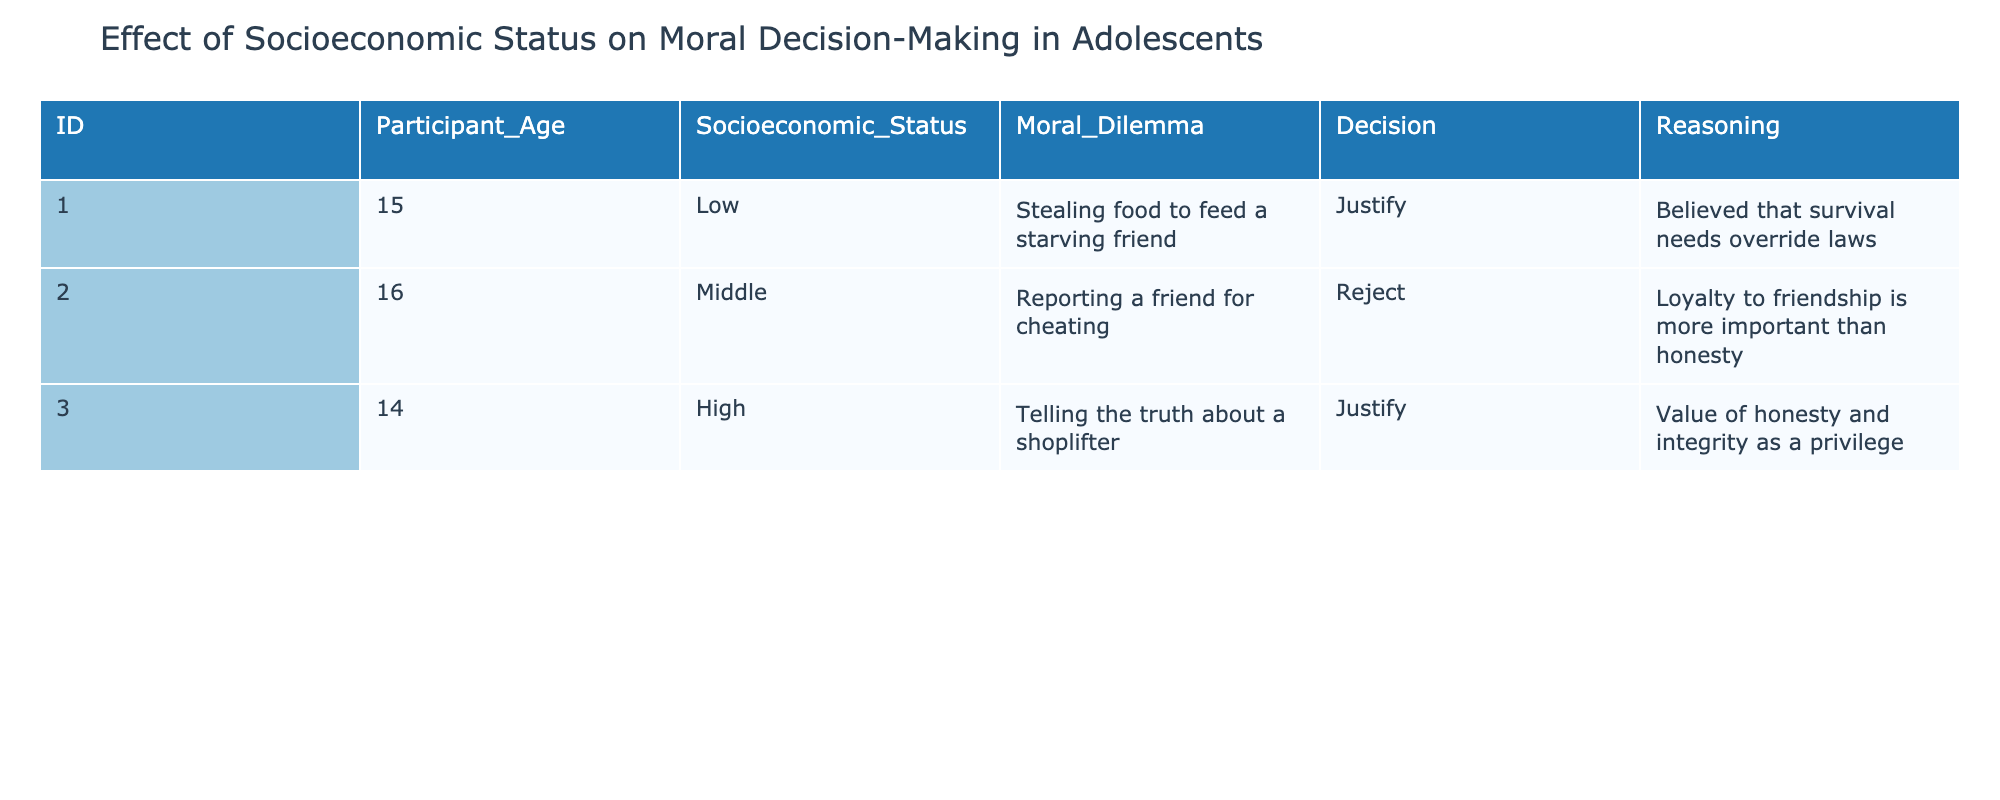What is the decision made by the participant aged 15 with low socioeconomic status? The table shows that the participant aged 15 with low socioeconomic status made the decision to "Justify" stealing food to feed a starving friend.
Answer: Justify How many participants reported a decision to justify their actions? There are two participants with justifications: one is aged 15 (low socioeconomic status) and the other is aged 14 (high socioeconomic status). Therefore, the total number is 2.
Answer: 2 Did the participant with high socioeconomic status decide to reject a moral dilemma? The participant aged 14 with high socioeconomic status chose to justify their decision regarding telling the truth about a shoplifter, thus did not reject a moral dilemma.
Answer: No What reasoning did the participant with middle socioeconomic status provide for rejecting the moral dilemma? The participant aged 16 with middle socioeconomic status reasoned that loyalty to friendship is more important than honesty, which explains their decision to reject reporting a friend for cheating.
Answer: Loyalty to friendship is more important than honesty What is the average age of participants who justified their decisions? The participants who justified their decisions are aged 15 and 14. To find the average: (15 + 14) / 2 = 29 / 2 = 14.5.
Answer: 14.5 How many decisions were made in total about moral dilemmas involving stealing? The table shows one decision regarding stealing food to feed a starving friend, which corresponds to just one case out of the three total participants.
Answer: 1 Did any participant justify their decision related to honesty? Yes, the participant aged 14 with high socioeconomic status justified telling the truth about a shoplifter, indicating a belief in the value of honesty and integrity.
Answer: Yes What percentage of the participants come from a low socioeconomic status? There are three participants in total, and only one participant is from a low socioeconomic status, which gives us (1/3) * 100 = 33.33%.
Answer: 33.33% What is the reasoning behind the decision made by the participant aged 16? The participant aged 16, who has a middle socioeconomic status, rejected the moral dilemma of reporting a friend for cheating because of the belief that loyalty to friendship is more important than honesty.
Answer: Loyalty to friendship is more important than honesty 